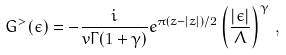Convert formula to latex. <formula><loc_0><loc_0><loc_500><loc_500>G ^ { > } ( \epsilon ) = - \frac { i } { v \Gamma ( 1 + \gamma ) } e ^ { \pi ( z - | z | ) / 2 } \left ( \frac { | \epsilon | } { \Lambda } \right ) ^ { \gamma } \, ,</formula> 